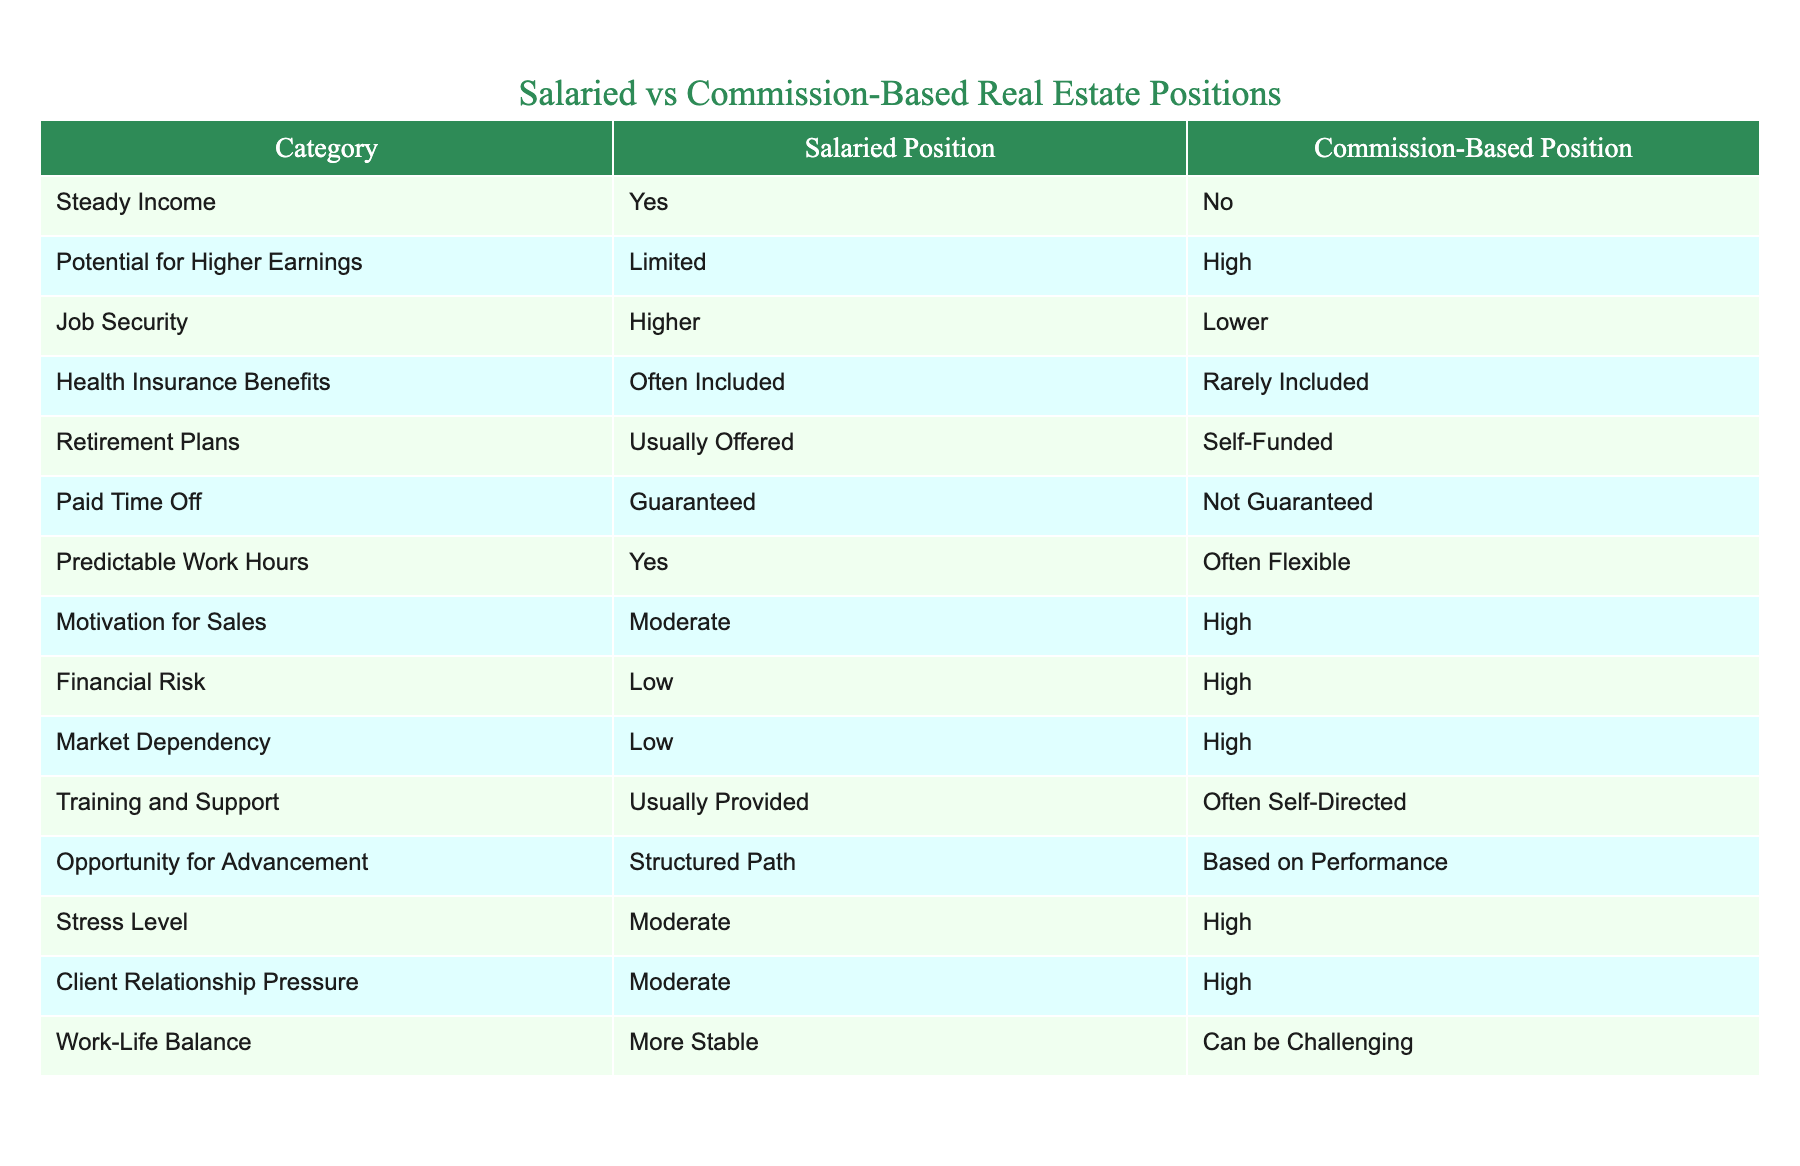What is the job security like for salaried positions compared to commission-based positions? The table shows that salaried positions have higher job security (labeled as "Higher") while commission-based positions have lower job security (labeled as "Lower").
Answer: Higher for salaried, Lower for commission-based Is health insurance typically included in salaried positions? According to the table, health insurance benefits are often included in salaried positions, as indicated by "Often Included".
Answer: Yes What are the main motivations for sales in commission-based positions? The table signifies a high motivation for sales in commission-based positions (marked as "High"), indicating the nature of income dependency on performance increases motivation.
Answer: High How do paid time off policies differ between salaried and commission-based positions? The table states that salaried positions guarantee paid time off (marked as "Guaranteed"), while commission-based positions do not guarantee paid time off (marked as "Not Guaranteed").
Answer: Salaried guarantees; Commission does not What is the difference in financial risk between salaried and commission-based positions? The table outlines that salaried positions entail low financial risk (marked as "Low"), whereas commission-based positions involve high financial risk (marked as "High"). This shows that commission-based roles greatly depend on market conditions.
Answer: Low for salaried; High for commission-based If a person is aiming for a stable work-life balance, which position would you recommend? The table indicates that salaried positions provide a more stable work-life balance (marked as "More Stable") compared to commission-based positions, which can be challenging (marked as "Can be Challenging"). It suggests that salaried roles may be preferable for those prioritizing stability.
Answer: Salaried positions What are the implications of having a structured path for advancement in salaried roles? From the table, we see that salaried positions offer a structured path for advancement, which may imply predictable and attainable career progression. In contrast, commission-based positions rely on performance, indicating variability and greater uncertainty in advancement opportunities.
Answer: Predictable in salaried; Variable in commission-based How does market dependency differ between salary vs. commission-based roles? The table highlights that salaried positions have low market dependency (marked as "Low"), while commission-based roles experience high market dependency (marked as "High"). This means salaried positions are less affected by market fluctuations compared to commission roles whose income may greatly vary with market conditions.
Answer: Low for salaried; High for commission-based 